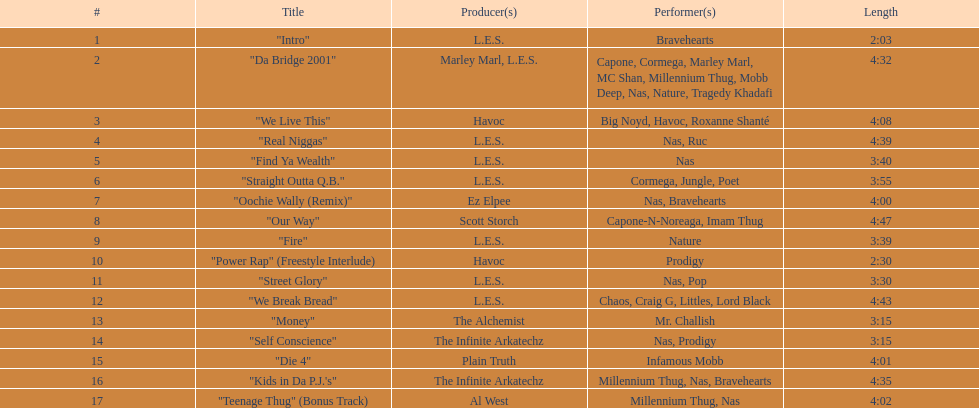What is the appellation of the ultimate song on the album? "Teenage Thug" (Bonus Track). 